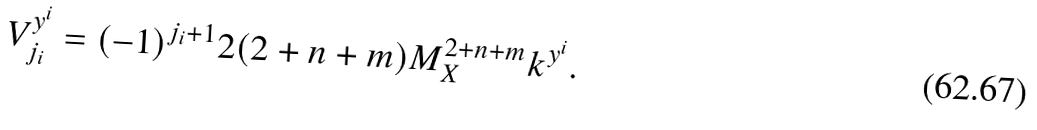<formula> <loc_0><loc_0><loc_500><loc_500>V _ { j _ { i } } ^ { y ^ { i } } = ( - 1 ) ^ { j _ { i } + 1 } 2 ( 2 + n + m ) M _ { X } ^ { 2 + n + m } k ^ { y ^ { i } } .</formula> 